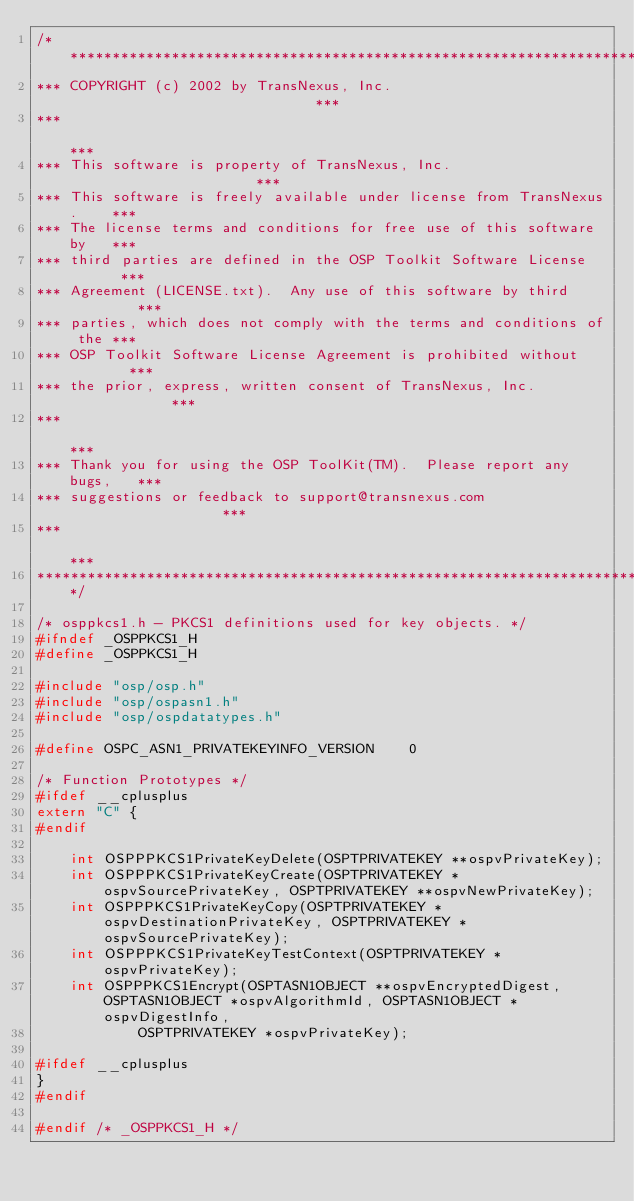<code> <loc_0><loc_0><loc_500><loc_500><_C_>/**************************************************************************
*** COPYRIGHT (c) 2002 by TransNexus, Inc.                              ***
***                                                                     ***
*** This software is property of TransNexus, Inc.                       ***
*** This software is freely available under license from TransNexus.    ***
*** The license terms and conditions for free use of this software by   ***
*** third parties are defined in the OSP Toolkit Software License       ***
*** Agreement (LICENSE.txt).  Any use of this software by third         ***
*** parties, which does not comply with the terms and conditions of the ***
*** OSP Toolkit Software License Agreement is prohibited without        ***
*** the prior, express, written consent of TransNexus, Inc.             ***
***                                                                     ***
*** Thank you for using the OSP ToolKit(TM).  Please report any bugs,   ***
*** suggestions or feedback to support@transnexus.com                   ***
***                                                                     ***
**************************************************************************/

/* osppkcs1.h - PKCS1 definitions used for key objects. */
#ifndef _OSPPKCS1_H
#define _OSPPKCS1_H

#include "osp/osp.h"
#include "osp/ospasn1.h"
#include "osp/ospdatatypes.h"

#define OSPC_ASN1_PRIVATEKEYINFO_VERSION    0

/* Function Prototypes */
#ifdef __cplusplus
extern "C" {
#endif

    int OSPPPKCS1PrivateKeyDelete(OSPTPRIVATEKEY **ospvPrivateKey);
    int OSPPPKCS1PrivateKeyCreate(OSPTPRIVATEKEY *ospvSourcePrivateKey, OSPTPRIVATEKEY **ospvNewPrivateKey);
    int OSPPPKCS1PrivateKeyCopy(OSPTPRIVATEKEY *ospvDestinationPrivateKey, OSPTPRIVATEKEY *ospvSourcePrivateKey);
    int OSPPPKCS1PrivateKeyTestContext(OSPTPRIVATEKEY *ospvPrivateKey);
    int OSPPPKCS1Encrypt(OSPTASN1OBJECT **ospvEncryptedDigest, OSPTASN1OBJECT *ospvAlgorithmId, OSPTASN1OBJECT *ospvDigestInfo,
            OSPTPRIVATEKEY *ospvPrivateKey);

#ifdef __cplusplus
}
#endif

#endif /* _OSPPKCS1_H */
</code> 